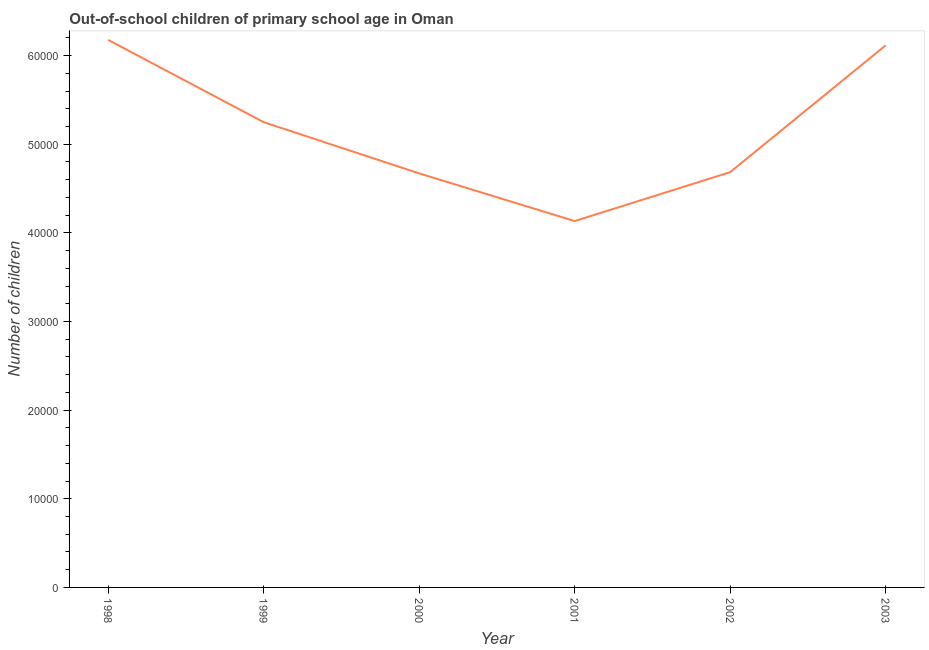What is the number of out-of-school children in 1999?
Make the answer very short. 5.25e+04. Across all years, what is the maximum number of out-of-school children?
Your answer should be very brief. 6.18e+04. Across all years, what is the minimum number of out-of-school children?
Your answer should be very brief. 4.13e+04. In which year was the number of out-of-school children maximum?
Your answer should be very brief. 1998. What is the sum of the number of out-of-school children?
Provide a short and direct response. 3.10e+05. What is the difference between the number of out-of-school children in 2001 and 2002?
Offer a very short reply. -5513. What is the average number of out-of-school children per year?
Offer a very short reply. 5.17e+04. What is the median number of out-of-school children?
Make the answer very short. 4.97e+04. In how many years, is the number of out-of-school children greater than 44000 ?
Ensure brevity in your answer.  5. Do a majority of the years between 2003 and 2002 (inclusive) have number of out-of-school children greater than 14000 ?
Make the answer very short. No. What is the ratio of the number of out-of-school children in 2001 to that in 2002?
Your answer should be very brief. 0.88. Is the number of out-of-school children in 2000 less than that in 2002?
Make the answer very short. Yes. What is the difference between the highest and the second highest number of out-of-school children?
Provide a short and direct response. 623. What is the difference between the highest and the lowest number of out-of-school children?
Give a very brief answer. 2.04e+04. In how many years, is the number of out-of-school children greater than the average number of out-of-school children taken over all years?
Offer a very short reply. 3. How many lines are there?
Make the answer very short. 1. How many years are there in the graph?
Your response must be concise. 6. Does the graph contain any zero values?
Ensure brevity in your answer.  No. What is the title of the graph?
Make the answer very short. Out-of-school children of primary school age in Oman. What is the label or title of the X-axis?
Offer a terse response. Year. What is the label or title of the Y-axis?
Offer a very short reply. Number of children. What is the Number of children in 1998?
Keep it short and to the point. 6.18e+04. What is the Number of children in 1999?
Keep it short and to the point. 5.25e+04. What is the Number of children of 2000?
Keep it short and to the point. 4.67e+04. What is the Number of children in 2001?
Ensure brevity in your answer.  4.13e+04. What is the Number of children of 2002?
Your response must be concise. 4.68e+04. What is the Number of children of 2003?
Make the answer very short. 6.11e+04. What is the difference between the Number of children in 1998 and 1999?
Provide a succinct answer. 9282. What is the difference between the Number of children in 1998 and 2000?
Give a very brief answer. 1.51e+04. What is the difference between the Number of children in 1998 and 2001?
Provide a short and direct response. 2.04e+04. What is the difference between the Number of children in 1998 and 2002?
Your response must be concise. 1.49e+04. What is the difference between the Number of children in 1998 and 2003?
Offer a terse response. 623. What is the difference between the Number of children in 1999 and 2000?
Make the answer very short. 5778. What is the difference between the Number of children in 1999 and 2001?
Give a very brief answer. 1.12e+04. What is the difference between the Number of children in 1999 and 2002?
Give a very brief answer. 5643. What is the difference between the Number of children in 1999 and 2003?
Keep it short and to the point. -8659. What is the difference between the Number of children in 2000 and 2001?
Ensure brevity in your answer.  5378. What is the difference between the Number of children in 2000 and 2002?
Offer a terse response. -135. What is the difference between the Number of children in 2000 and 2003?
Provide a short and direct response. -1.44e+04. What is the difference between the Number of children in 2001 and 2002?
Give a very brief answer. -5513. What is the difference between the Number of children in 2001 and 2003?
Offer a terse response. -1.98e+04. What is the difference between the Number of children in 2002 and 2003?
Your answer should be compact. -1.43e+04. What is the ratio of the Number of children in 1998 to that in 1999?
Give a very brief answer. 1.18. What is the ratio of the Number of children in 1998 to that in 2000?
Make the answer very short. 1.32. What is the ratio of the Number of children in 1998 to that in 2001?
Your answer should be very brief. 1.5. What is the ratio of the Number of children in 1998 to that in 2002?
Your answer should be compact. 1.32. What is the ratio of the Number of children in 1998 to that in 2003?
Ensure brevity in your answer.  1.01. What is the ratio of the Number of children in 1999 to that in 2000?
Provide a succinct answer. 1.12. What is the ratio of the Number of children in 1999 to that in 2001?
Your response must be concise. 1.27. What is the ratio of the Number of children in 1999 to that in 2002?
Provide a short and direct response. 1.12. What is the ratio of the Number of children in 1999 to that in 2003?
Your response must be concise. 0.86. What is the ratio of the Number of children in 2000 to that in 2001?
Keep it short and to the point. 1.13. What is the ratio of the Number of children in 2000 to that in 2003?
Ensure brevity in your answer.  0.76. What is the ratio of the Number of children in 2001 to that in 2002?
Your answer should be very brief. 0.88. What is the ratio of the Number of children in 2001 to that in 2003?
Your answer should be compact. 0.68. What is the ratio of the Number of children in 2002 to that in 2003?
Make the answer very short. 0.77. 